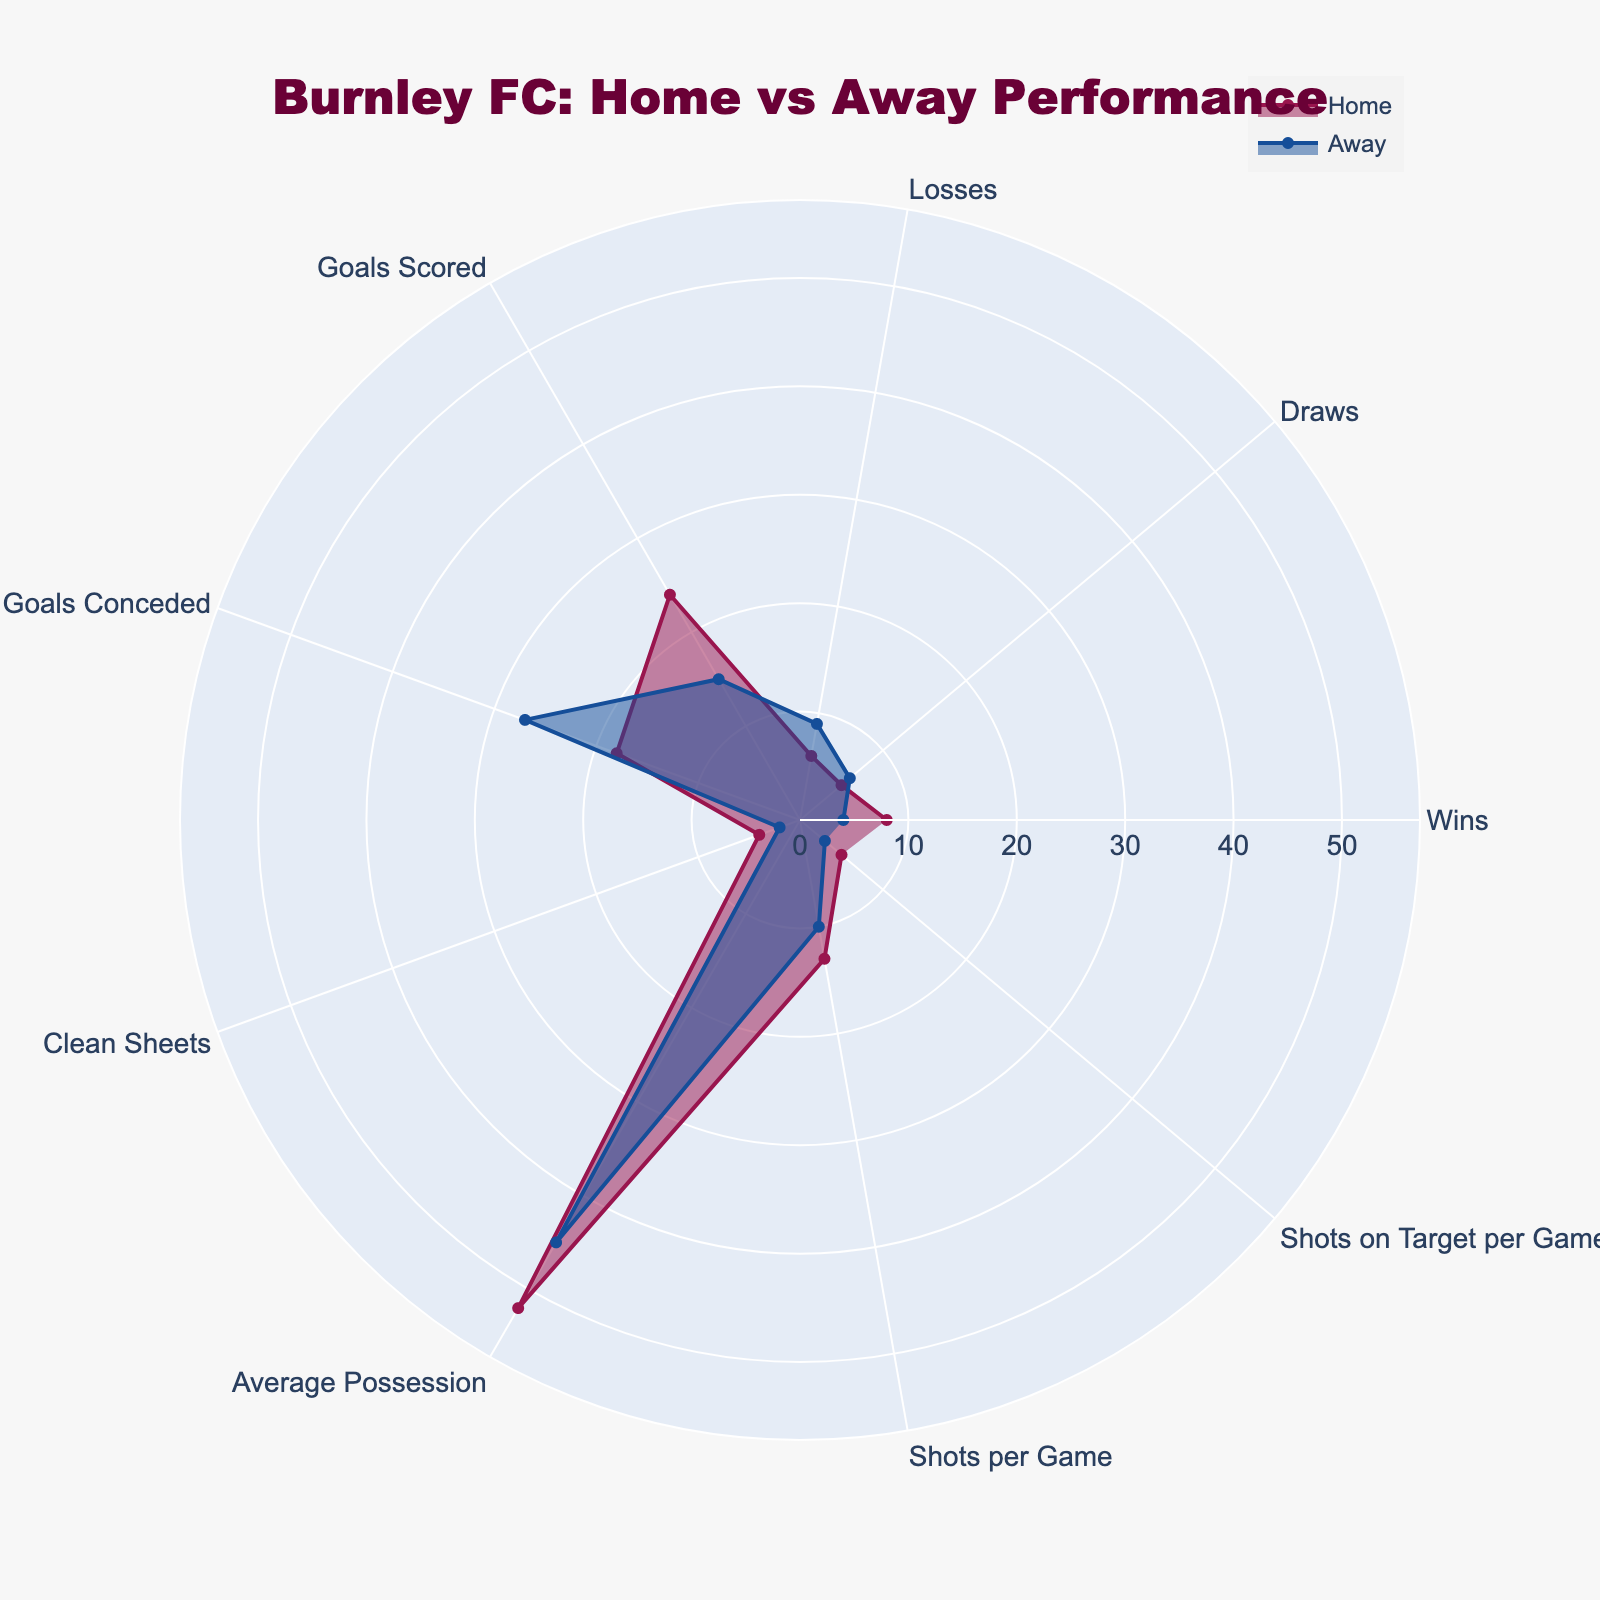Which category has the biggest difference in values between Home and Away? To determine the category with the biggest difference, subtract each Away value from its corresponding Home value. These are the differences: Wins (4), Draws (1), Losses (3), Goals Scored (9), Goals Conceded (-9), Clean Sheets (2), Average Possession (7), Shots per Game (3), Shots on Target per Game (2). The biggest difference is in Goals Conceded with -9.
Answer: Goals Conceded What are the two categories where Burnley performs better at Home than Away and by how much? Compare the Home and Away values for each category and identify the two smallest differences where the Home value is greater than the Away value. The differences for categories where Home is better are: Wins (4), Goals Scored (9), Clean Sheets (2), Average Possession (7), Shots per Game (3), Shots on Target per Game (2). The two smallest differences are Clean Sheets (2) and Shots on Target per Game (2).
Answer: Clean Sheets (2), Shots on Target per Game (2) Which category shows the same value at Home and Away? Compare the Home and Away values and identify if any category has equal values. No category has the same values in this data set.
Answer: None What's the average number of Wins for Home and Away matches? To find the average, sum the number of Wins at Home (8) and Away (4), then divide by 2. The calculation is (8 + 4) / 2.
Answer: 6 How does the average possession compare between Home and Away? Compare the Average Possession category values for Home (52) and Away (45) by finding the difference. The calculation is 52 - 45.
Answer: 7 What is the total number of Clean Sheets for Burnley, both Home and Away? Sum the Clean Sheets values for Home (4) and Away (2). The calculation is 4 + 2.
Answer: 6 Between Home and Away, where does Burnley have more goals conceded? Compare the Goals Conceded values: Home (18) and Away (27). Since 27 is greater than 18, Burnley concedes more goals Away.
Answer: Away Which categories show Burnley performing better at Home? Compare each category's values for Home and Away where the Home value is greater than the Away value. The categories are Wins (8 > 4), Goals Scored (24 > 15), Clean Sheets (4 > 2), Average Possession (52 > 45), Shots per Game (13 > 10), and Shots on Target per Game (5 > 3).
Answer: Wins, Goals Scored, Clean Sheets, Average Possession, Shots per Game, Shots on Target per Game Which category indicates that Burnley needs to improve more in their Away matches? Compare the values and find the largest difference where Away is worse than Home. Goals Conceded (27 Away vs. 18 Home) shows the biggest negative difference (-9).
Answer: Goals Conceded What is the difference in the number of Draws between Home and Away matches? Subtract the number of Draws Away (6) from Draws at Home (5). The calculation is 6 - 5.
Answer: 1 